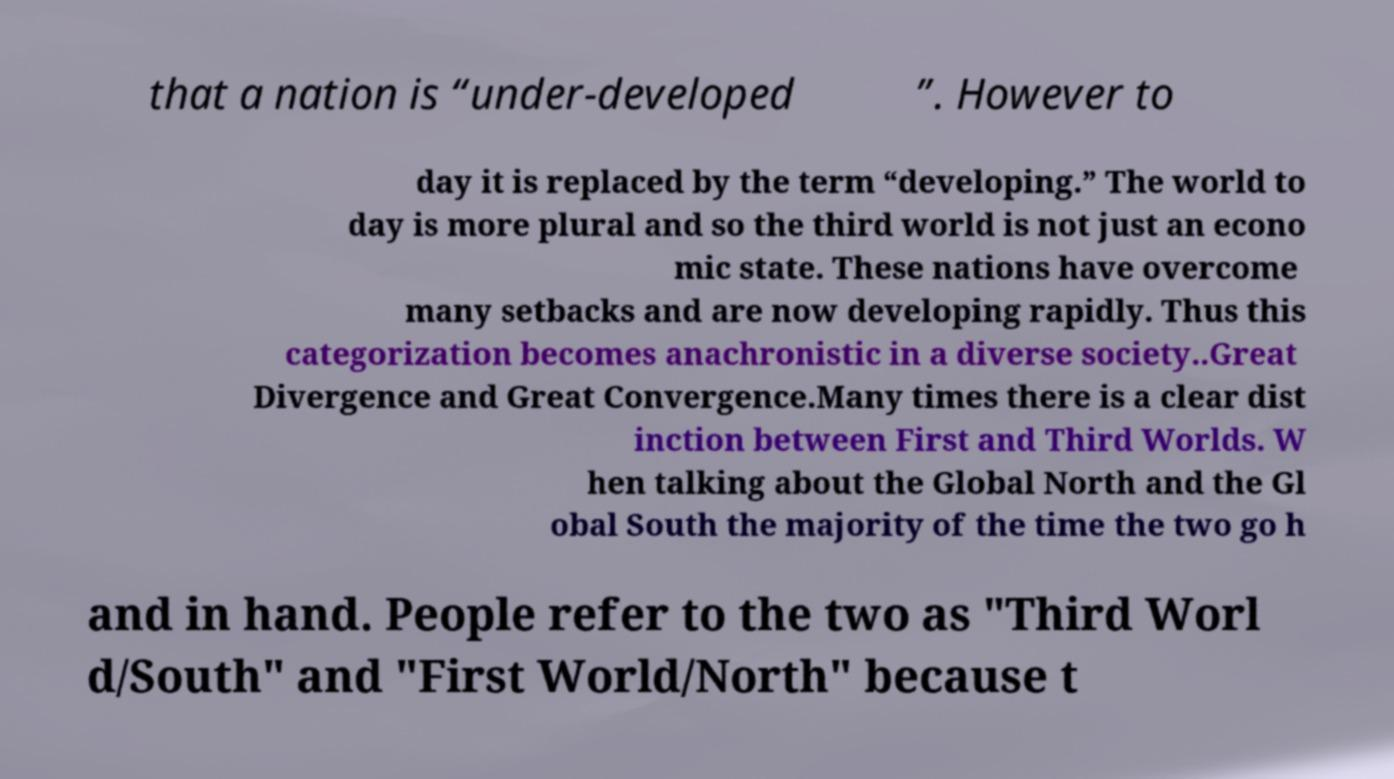I need the written content from this picture converted into text. Can you do that? that a nation is “under-developed ”. However to day it is replaced by the term “developing.” The world to day is more plural and so the third world is not just an econo mic state. These nations have overcome many setbacks and are now developing rapidly. Thus this categorization becomes anachronistic in a diverse society..Great Divergence and Great Convergence.Many times there is a clear dist inction between First and Third Worlds. W hen talking about the Global North and the Gl obal South the majority of the time the two go h and in hand. People refer to the two as "Third Worl d/South" and "First World/North" because t 